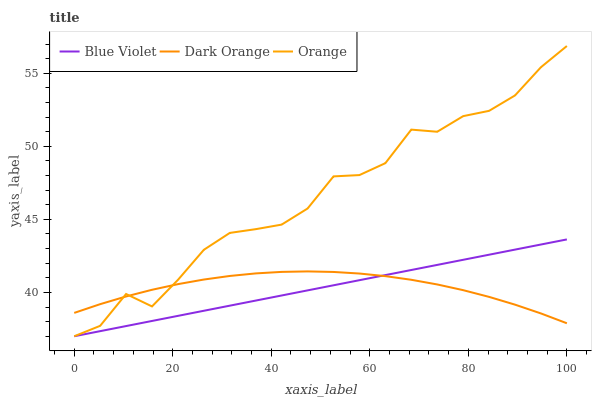Does Blue Violet have the minimum area under the curve?
Answer yes or no. Yes. Does Orange have the maximum area under the curve?
Answer yes or no. Yes. Does Dark Orange have the minimum area under the curve?
Answer yes or no. No. Does Dark Orange have the maximum area under the curve?
Answer yes or no. No. Is Blue Violet the smoothest?
Answer yes or no. Yes. Is Orange the roughest?
Answer yes or no. Yes. Is Dark Orange the smoothest?
Answer yes or no. No. Is Dark Orange the roughest?
Answer yes or no. No. Does Dark Orange have the lowest value?
Answer yes or no. No. Does Blue Violet have the highest value?
Answer yes or no. No. 